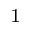<formula> <loc_0><loc_0><loc_500><loc_500>^ { 1 }</formula> 